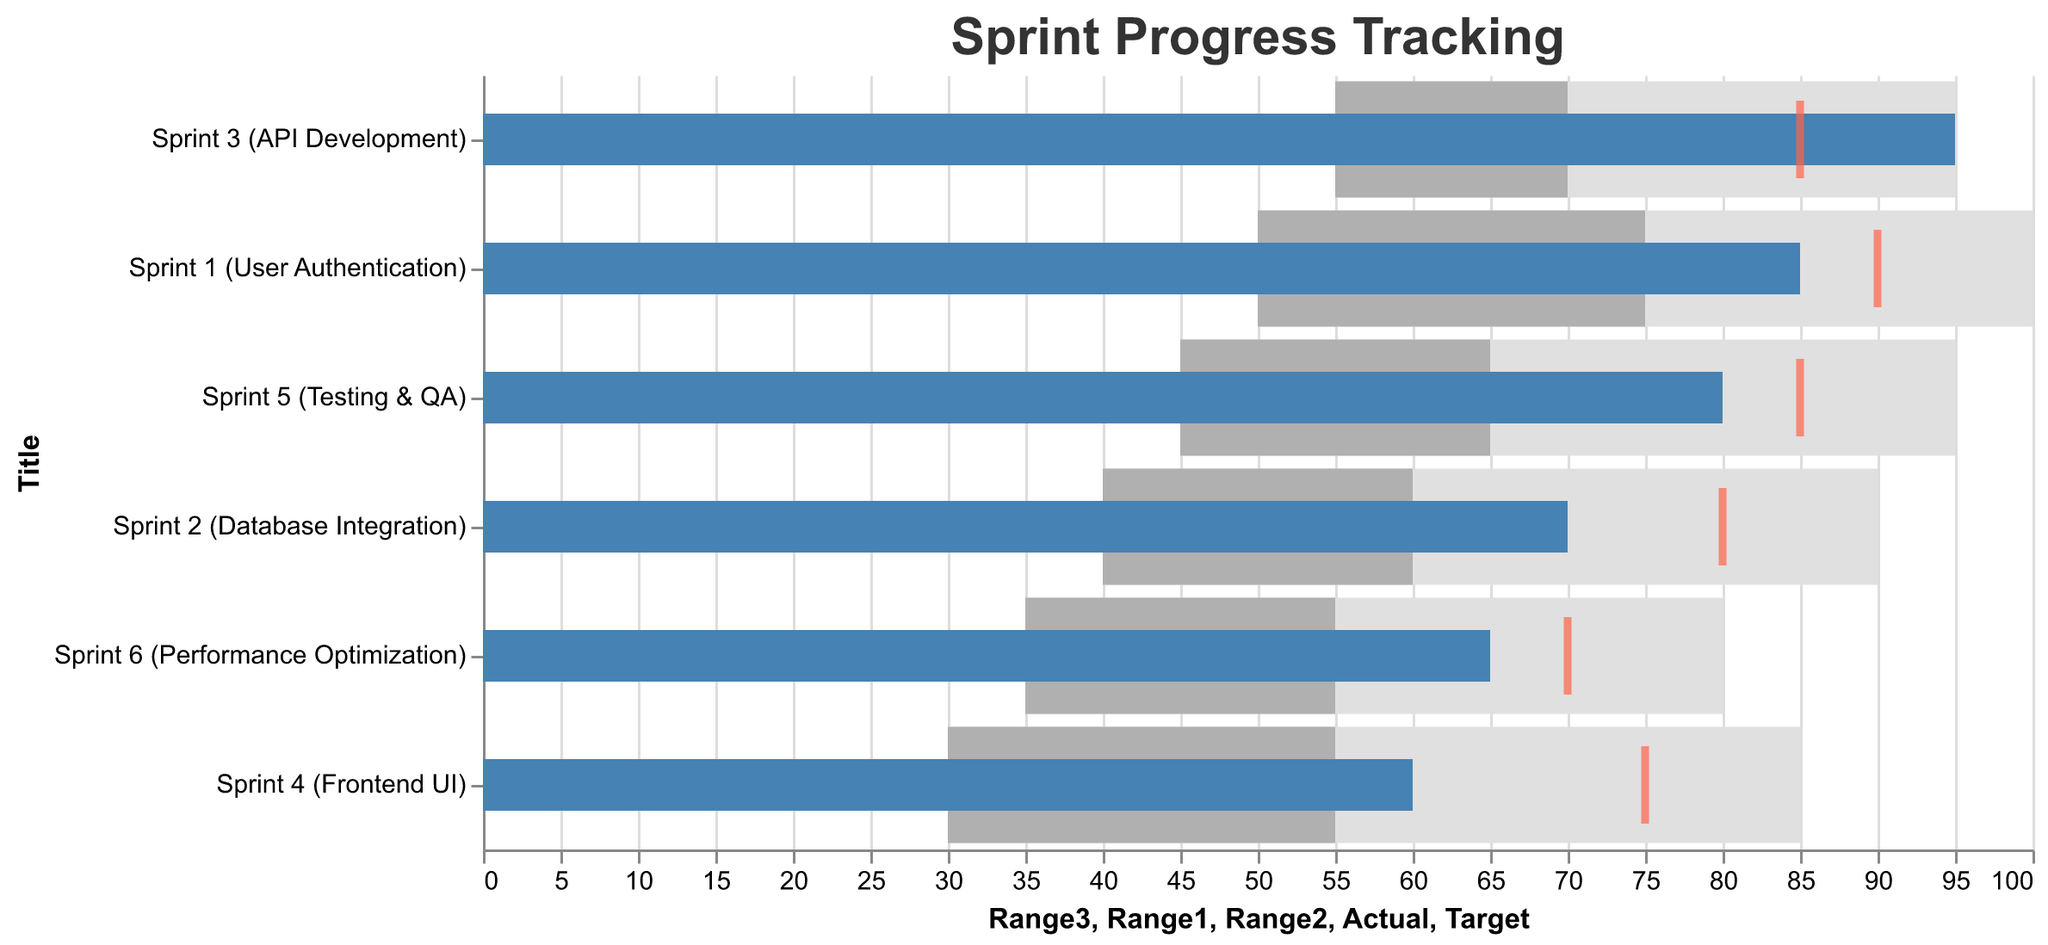What is the title of the chart? The title can be found at the top of the chart. It reads "Sprint Progress Tracking".
Answer: Sprint Progress Tracking Which sprint has the highest actual progress? By examining the "Actual" progress bars, the tallest bar corresponds to "Sprint 3 (API Development)" with an actual progress of 95.
Answer: Sprint 3 (API Development) How does Sprint 4 (Frontend UI) perform relative to its target? In Sprint 4, the actual progress is 60 while the target is 75. The actual progress falls short by 15.
Answer: 15 short Compare the actual progress of Sprint 1 (User Authentication) and Sprint 2 (Database Integration). Looking at the "Actual" bars for both, Sprint 1 has an actual progress of 85 and Sprint 2 has an actual progress of 70. Sprint 1 has a higher actual progress.
Answer: Sprint 1 (User Authentication) is higher Which sprint exceeded its target the most? Comparing the "Actual" and "Target" values, Sprint 3 has an actual progress of 95 against a target of 85, which is 10 above the target. No other sprint exceeds its target more.
Answer: Sprint 3 (API Development) Identify the sprint with the lowest actual progress. The shortest bar under "Actual" progress is Sprint 4 (Frontend UI) with an actual progress of 60.
Answer: Sprint 4 (Frontend UI) What are the performance ranges for Sprint 5 (Testing & QA)? For Sprint 5: Range1 is 45, Range2 is 65, and Range3 is 95.
Answer: Range1: 45, Range2: 65, Range3: 95 Which sprints have an actual progress greater than 80? Sprints with actual progress values above 80 are: Sprint 1 (85), Sprint 3 (95), and Sprint 5 (80).
Answer: Sprint 1, Sprint 3, and Sprint 5 What is the difference between the actual progress and target of Sprint 6 (Performance Optimization)? Sprint 6 has an actual progress of 65 and a target of 70. The difference is 70 - 65 = 5.
Answer: 5 Which sprint has the smallest gap between its actual progress and its target? The smallest gap occurs in Sprint 6 where the actual is 65 and the target is 70, giving a gap of 5.
Answer: Sprint 6 (Performance Optimization) 